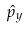Convert formula to latex. <formula><loc_0><loc_0><loc_500><loc_500>\hat { p } _ { y }</formula> 